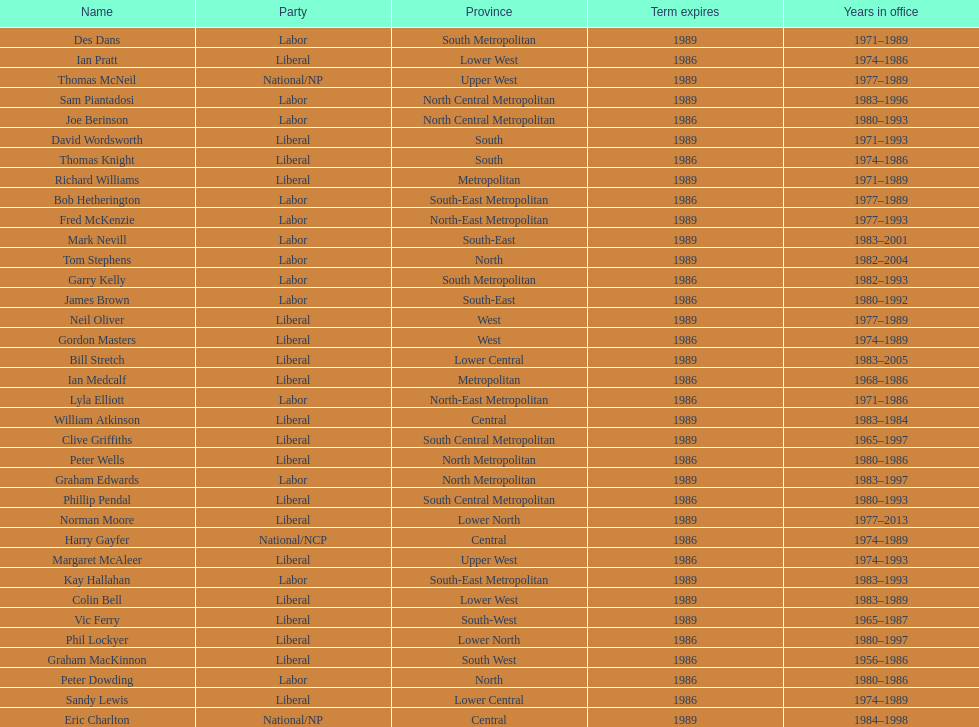How many members were party of lower west province? 2. 